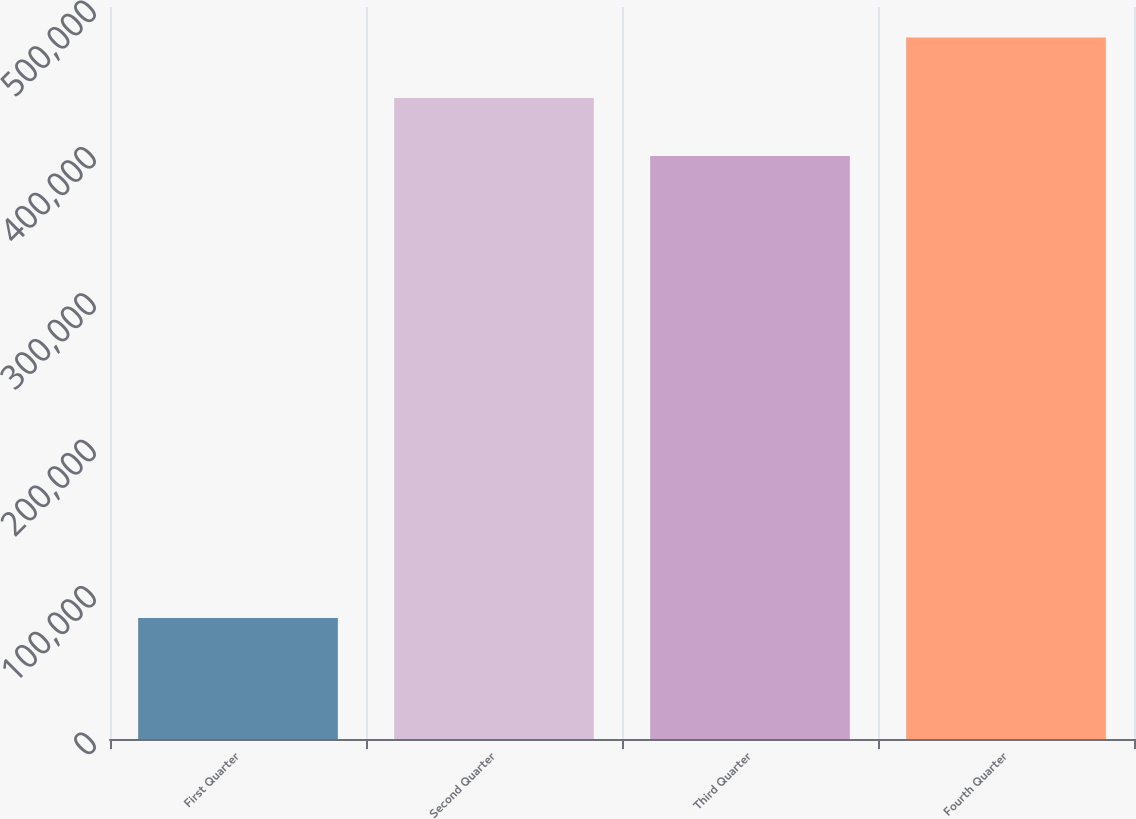Convert chart to OTSL. <chart><loc_0><loc_0><loc_500><loc_500><bar_chart><fcel>First Quarter<fcel>Second Quarter<fcel>Third Quarter<fcel>Fourth Quarter<nl><fcel>82605<fcel>437849<fcel>398198<fcel>479113<nl></chart> 